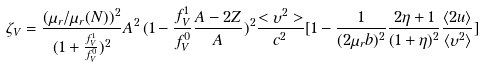Convert formula to latex. <formula><loc_0><loc_0><loc_500><loc_500>\zeta _ { V } = \frac { ( \mu _ { r } / \mu _ { r } ( N ) ) ^ { 2 } } { ( 1 + \frac { f ^ { 1 } _ { V } } { f ^ { 0 } _ { V } } ) ^ { 2 } } A ^ { 2 } \, ( 1 - \frac { f ^ { 1 } _ { V } } { f ^ { 0 } _ { V } } \frac { A - 2 Z } { A } ) ^ { 2 } \frac { < \upsilon ^ { 2 } > } { c ^ { 2 } } [ 1 - \frac { 1 } { ( 2 \mu _ { r } b ) ^ { 2 } } \frac { 2 \eta + 1 } { ( 1 + \eta ) ^ { 2 } } \frac { \langle 2 u \rangle } { \langle \upsilon ^ { 2 } \rangle } ]</formula> 